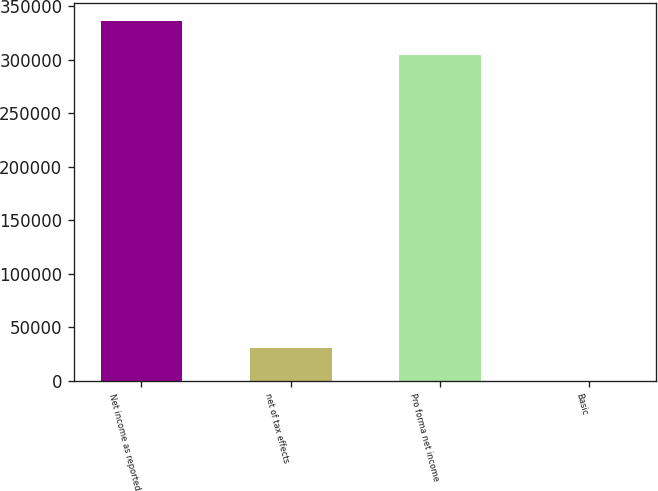Convert chart to OTSL. <chart><loc_0><loc_0><loc_500><loc_500><bar_chart><fcel>Net income as reported<fcel>net of tax effects<fcel>Pro forma net income<fcel>Basic<nl><fcel>336027<fcel>31123.2<fcel>304905<fcel>1.44<nl></chart> 